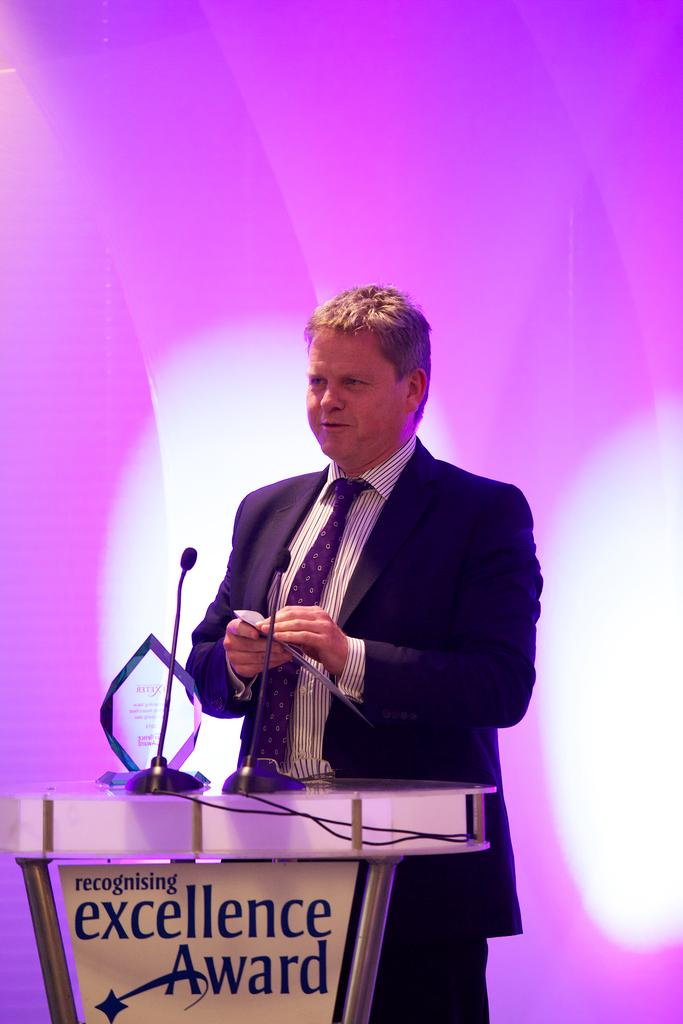What is the main subject of the image? There is a person standing in the image. What is the person wearing? The person is wearing a black blazer and a white color shirt. What can be seen in front of the person? There are two microphones on a podium in front of the person. What colors are present in the background of the image? The background of the image is pink and white in color. What type of treatment is the doctor providing in the garden in the image? There is no doctor or garden present in the image. The image features a person standing in front of a podium with microphones, wearing a black blazer and a white color shirt, with a pink and white background. 